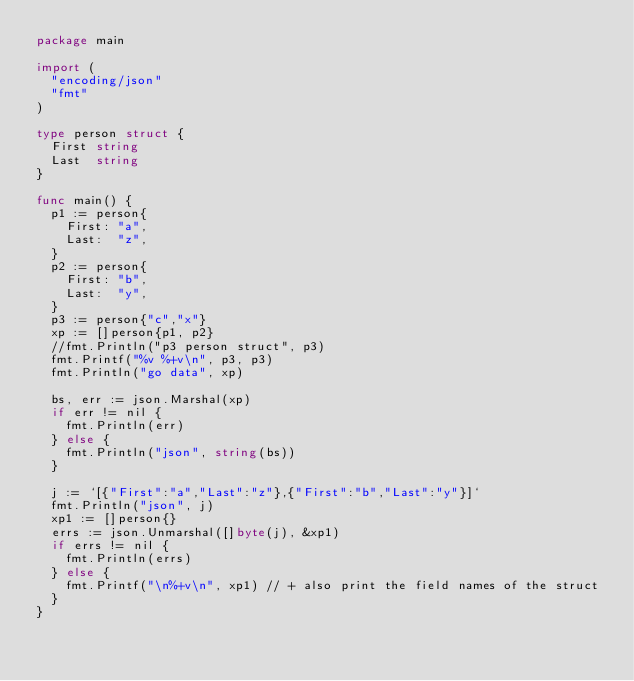Convert code to text. <code><loc_0><loc_0><loc_500><loc_500><_Go_>package main

import (
	"encoding/json"
	"fmt"
)

type person struct {
	First string
	Last  string
}

func main() {
	p1 := person{
		First: "a",
		Last:  "z",
	}
	p2 := person{
		First: "b",
		Last:  "y",
	}
  p3 := person{"c","x"}
	xp := []person{p1, p2}
  //fmt.Println("p3 person struct", p3)
  fmt.Printf("%v %+v\n", p3, p3)
	fmt.Println("go data", xp)

	bs, err := json.Marshal(xp)
	if err != nil {
		fmt.Println(err)
	} else {
		fmt.Println("json", string(bs))
	}

	j := `[{"First":"a","Last":"z"},{"First":"b","Last":"y"}]`
	fmt.Println("json", j)
	xp1 := []person{}
	errs := json.Unmarshal([]byte(j), &xp1)
	if errs != nil {
		fmt.Println(errs)
	} else {
    fmt.Printf("\n%+v\n", xp1) // + also print the field names of the struct
  }
}
</code> 